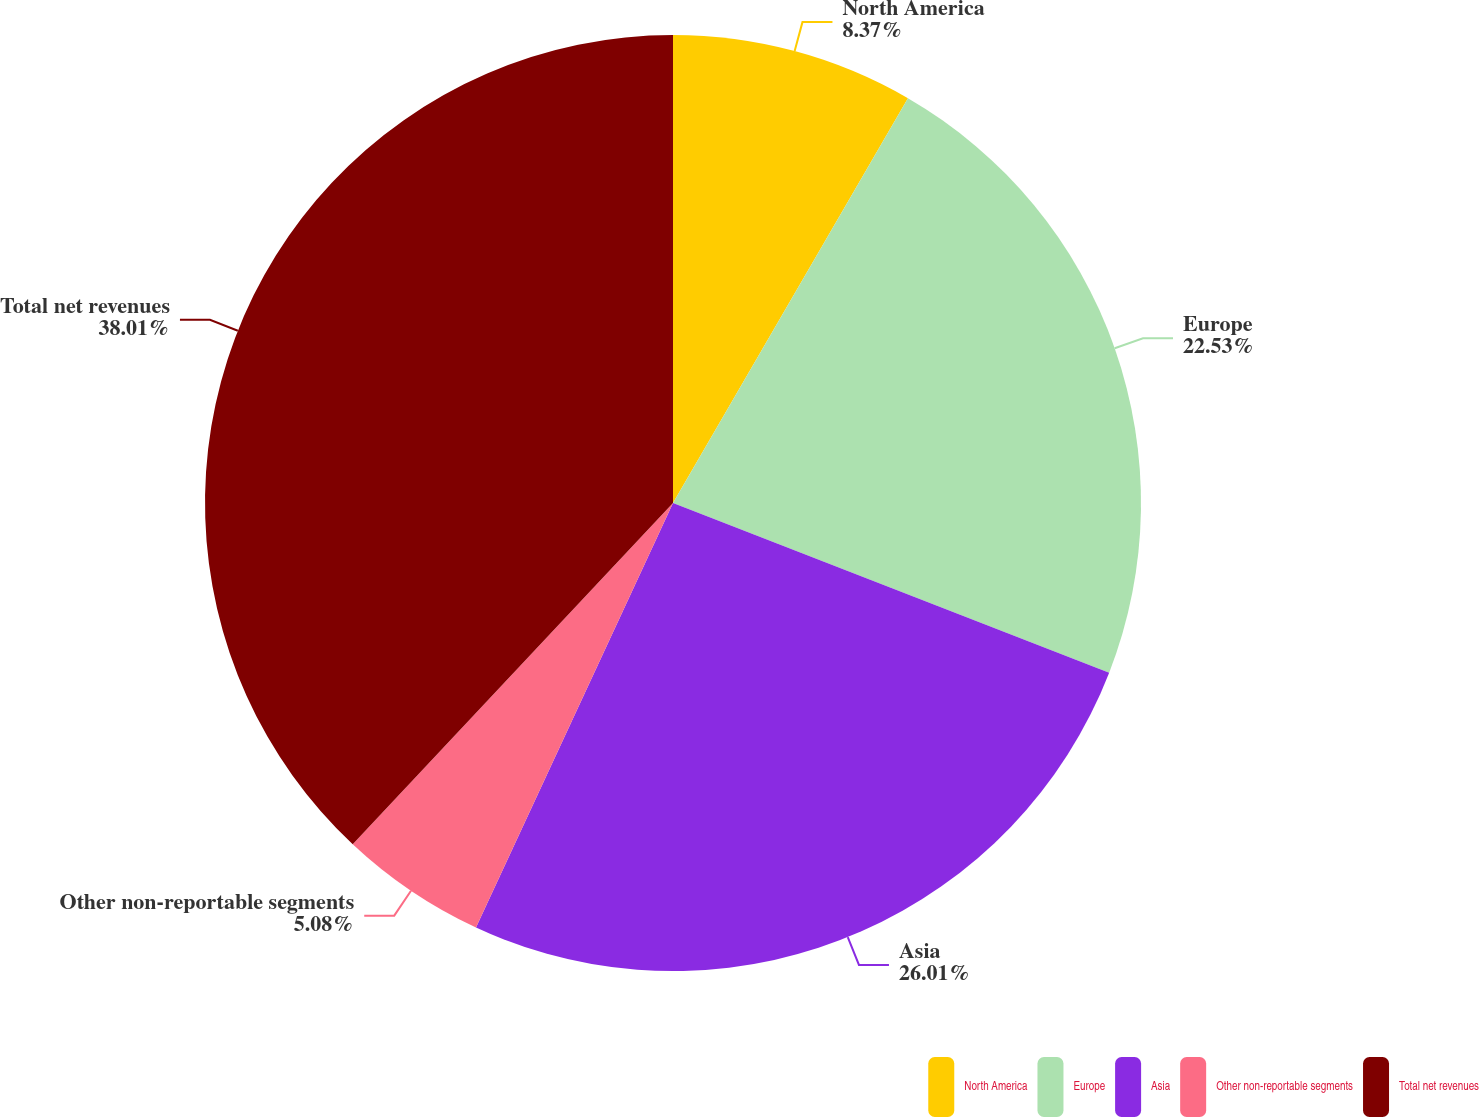<chart> <loc_0><loc_0><loc_500><loc_500><pie_chart><fcel>North America<fcel>Europe<fcel>Asia<fcel>Other non-reportable segments<fcel>Total net revenues<nl><fcel>8.37%<fcel>22.53%<fcel>26.01%<fcel>5.08%<fcel>38.0%<nl></chart> 